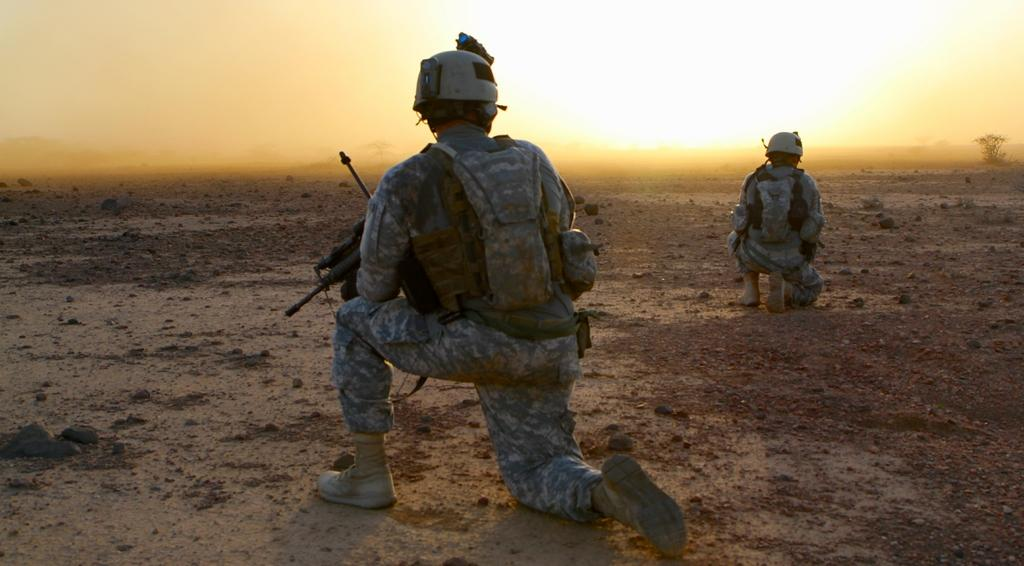What type of terrain is visible in the image? There is a ground with sand in the image. How many people are present in the image? There are two people in the image. What can be seen on the right side of the image? There is a tree on the right side of the image. What is visible in the background of the image? The sky is visible in the image. What type of creature is hiding in the sack in the image? There is no sack or creature present in the image. How many rings can be seen on the tree in the image? There are no rings visible on the tree in the image; it is a single tree without any rings or other markings. 